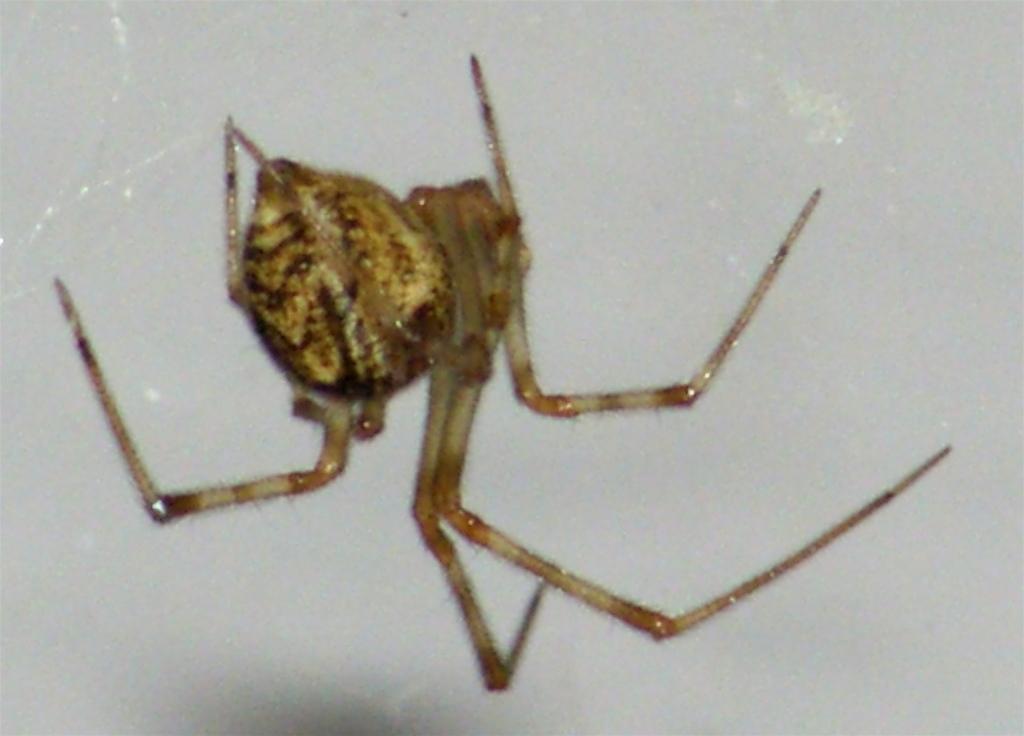Please provide a concise description of this image. In the image we can see a spider on a wall. 